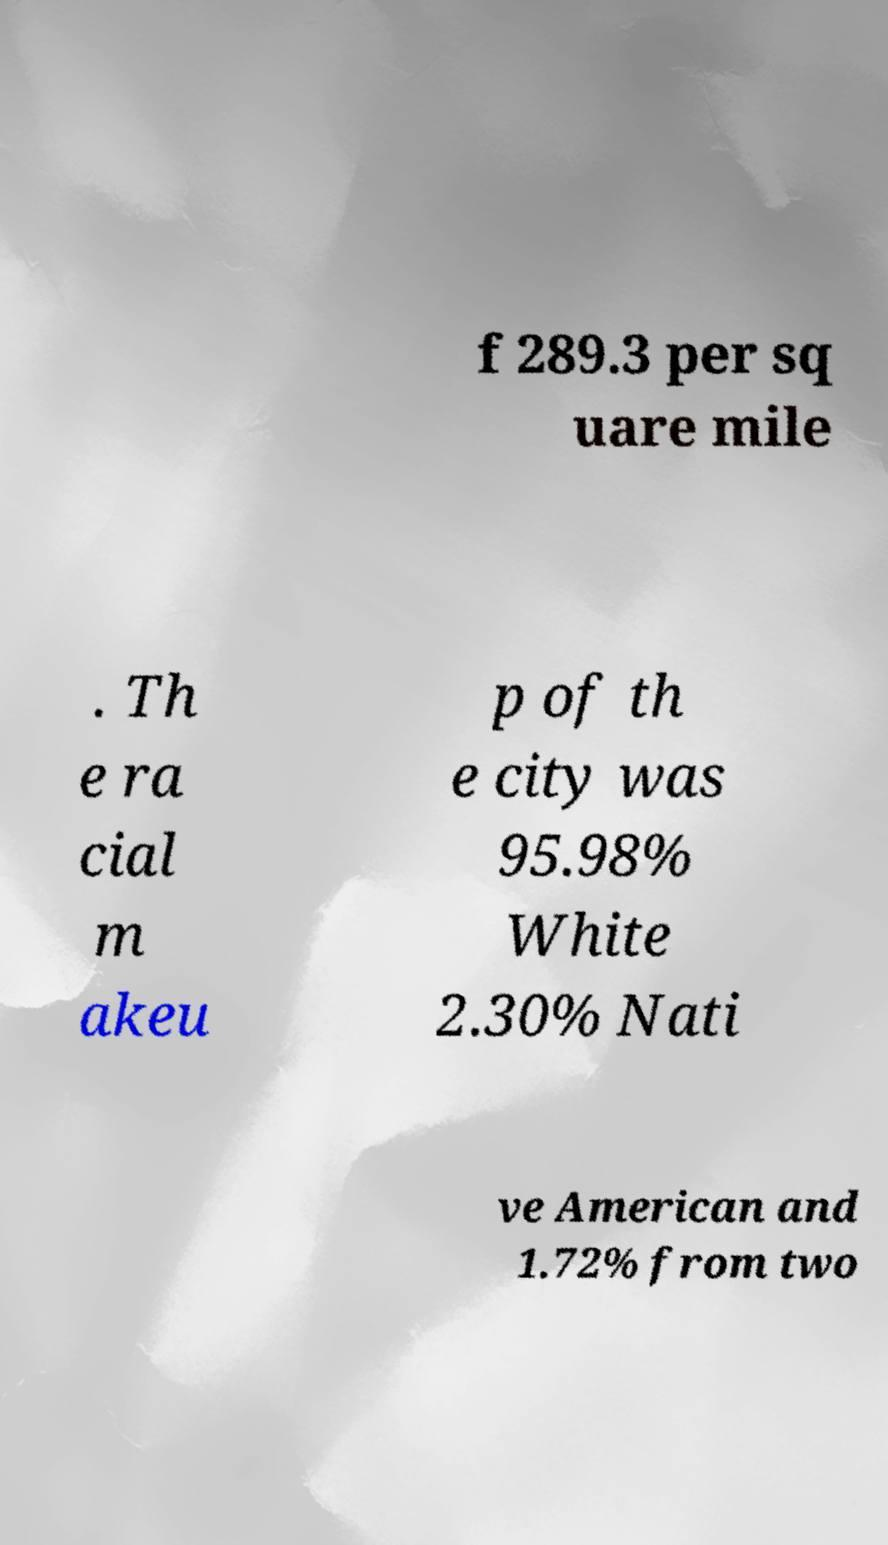There's text embedded in this image that I need extracted. Can you transcribe it verbatim? f 289.3 per sq uare mile . Th e ra cial m akeu p of th e city was 95.98% White 2.30% Nati ve American and 1.72% from two 